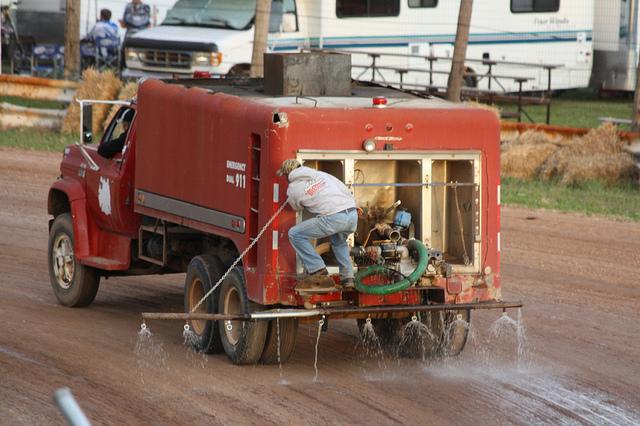Is the man trying to steal something off the truck?
Concise answer only. No. What color is the truck?
Keep it brief. Red. Is this in a city area?
Answer briefly. No. 